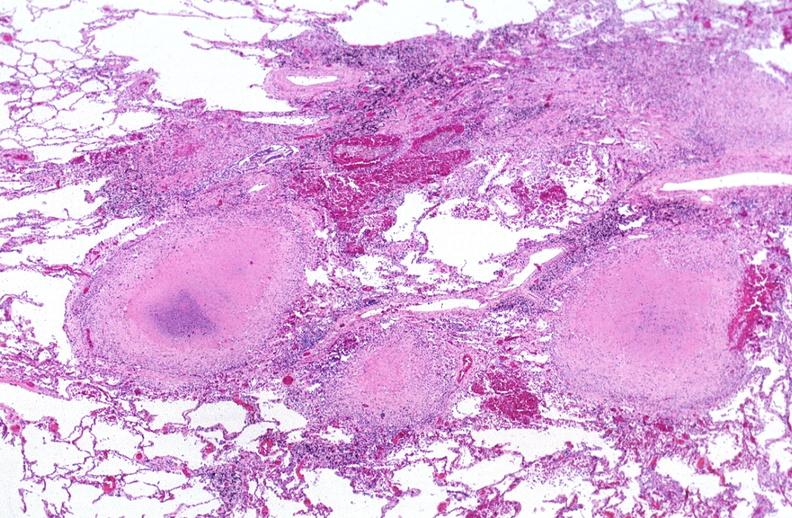s respiratory present?
Answer the question using a single word or phrase. Yes 